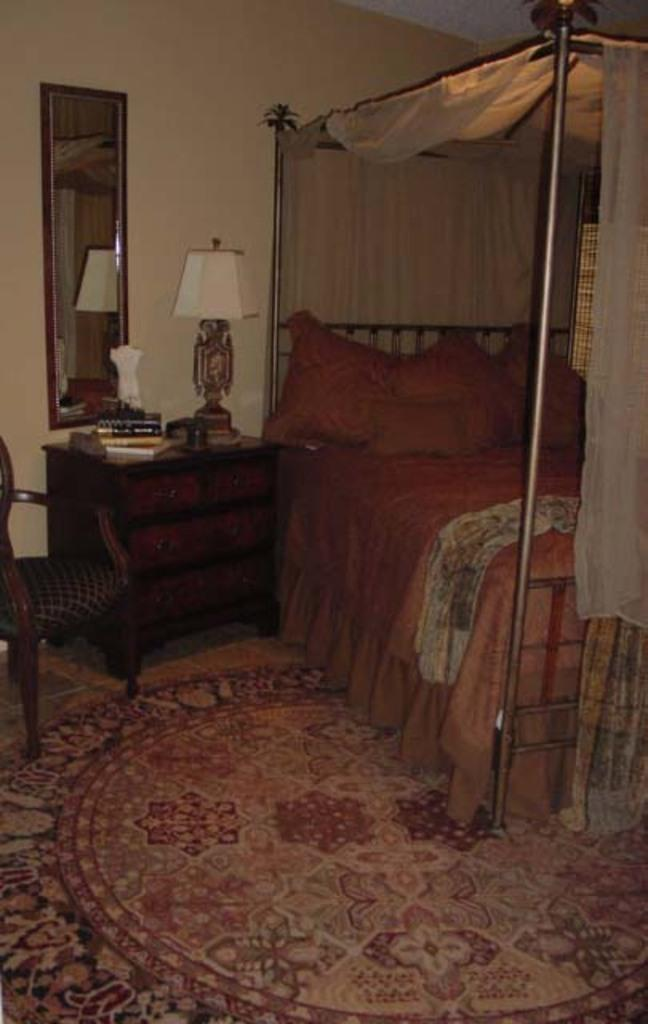What type of furniture is present in the image? There is a bed, a drawer, a lamp, a mirror, and a chair in the image. What is located below the mirror in the image? There is a drawer in the image, and things are placed on it. What might be used for illumination in the image? There is a lamp in the image that could be used for illumination. What object might be used for personal grooming or reflection in the image? There is a mirror in the image that could be used for personal grooming or reflection. What type of land can be seen through the window in the image? There is no window or land visible in the image; it only contains furniture items. What color is the leaf on the chair in the image? There is no leaf present on the chair or anywhere else in the image. 